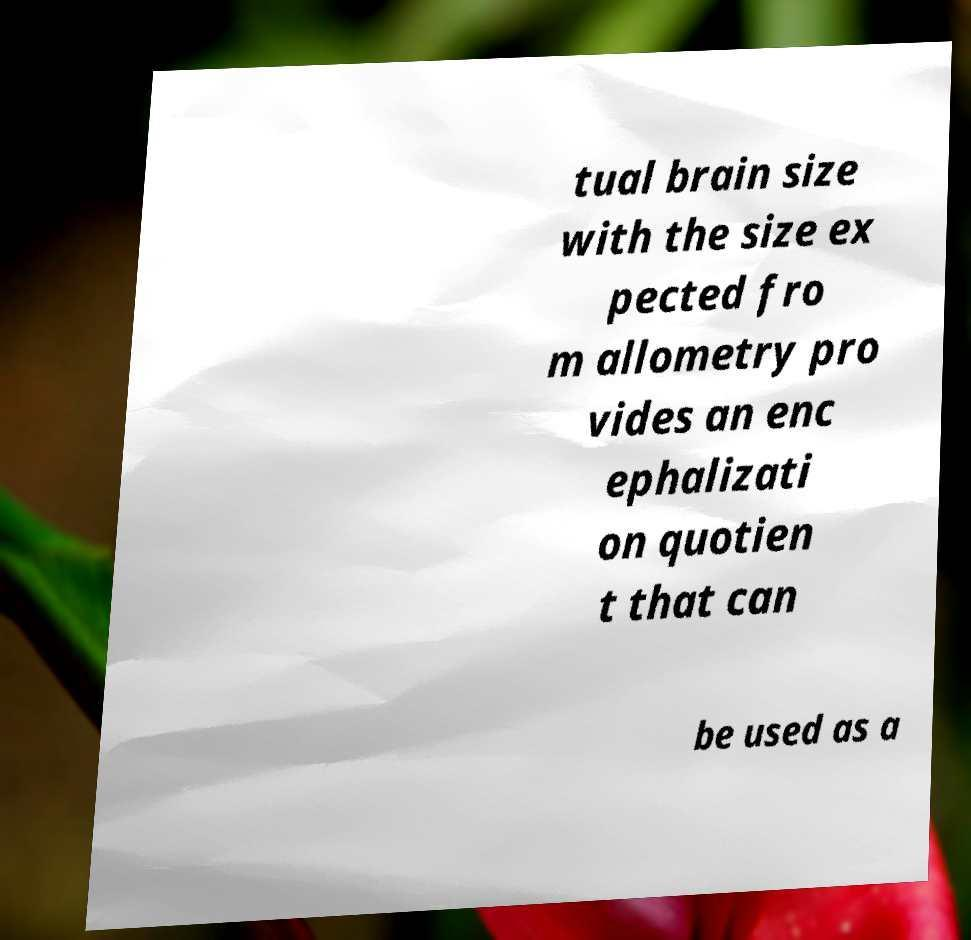What messages or text are displayed in this image? I need them in a readable, typed format. tual brain size with the size ex pected fro m allometry pro vides an enc ephalizati on quotien t that can be used as a 